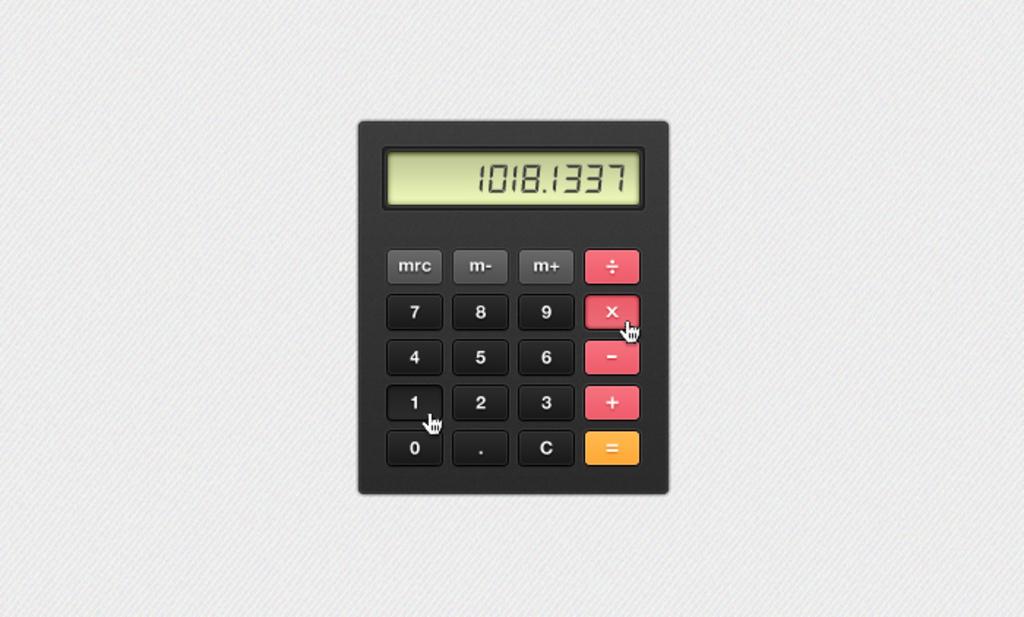What are the last four numbers on the calculator display?
Provide a succinct answer. 1337. 